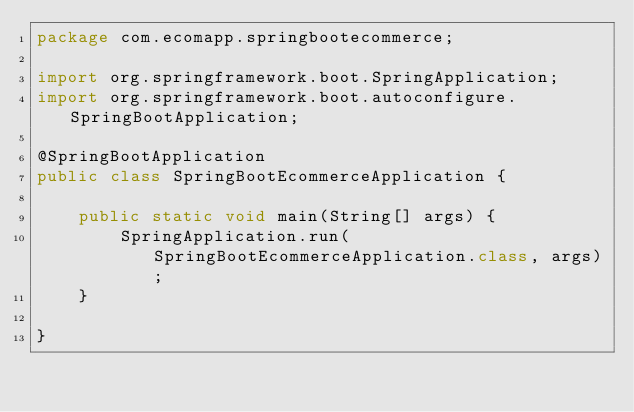Convert code to text. <code><loc_0><loc_0><loc_500><loc_500><_Java_>package com.ecomapp.springbootecommerce;

import org.springframework.boot.SpringApplication;
import org.springframework.boot.autoconfigure.SpringBootApplication;

@SpringBootApplication
public class SpringBootEcommerceApplication {

	public static void main(String[] args) {
		SpringApplication.run(SpringBootEcommerceApplication.class, args);
	}

}
</code> 